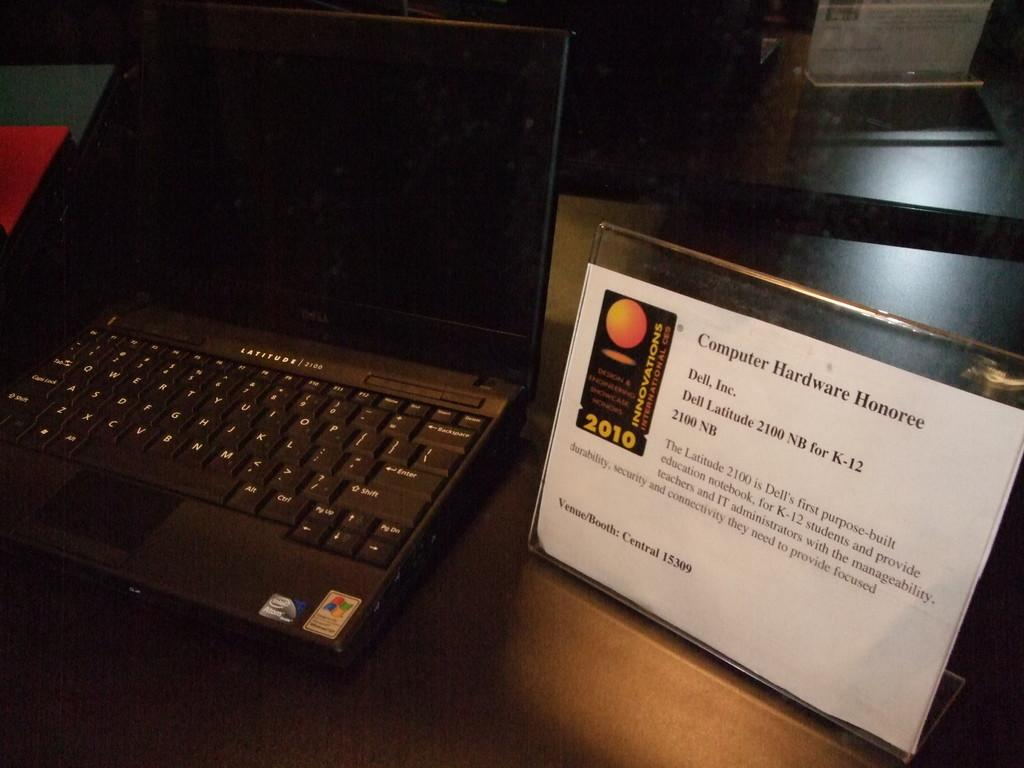<image>
Share a concise interpretation of the image provided. A computer screen shows the year 2010 on the left side. 